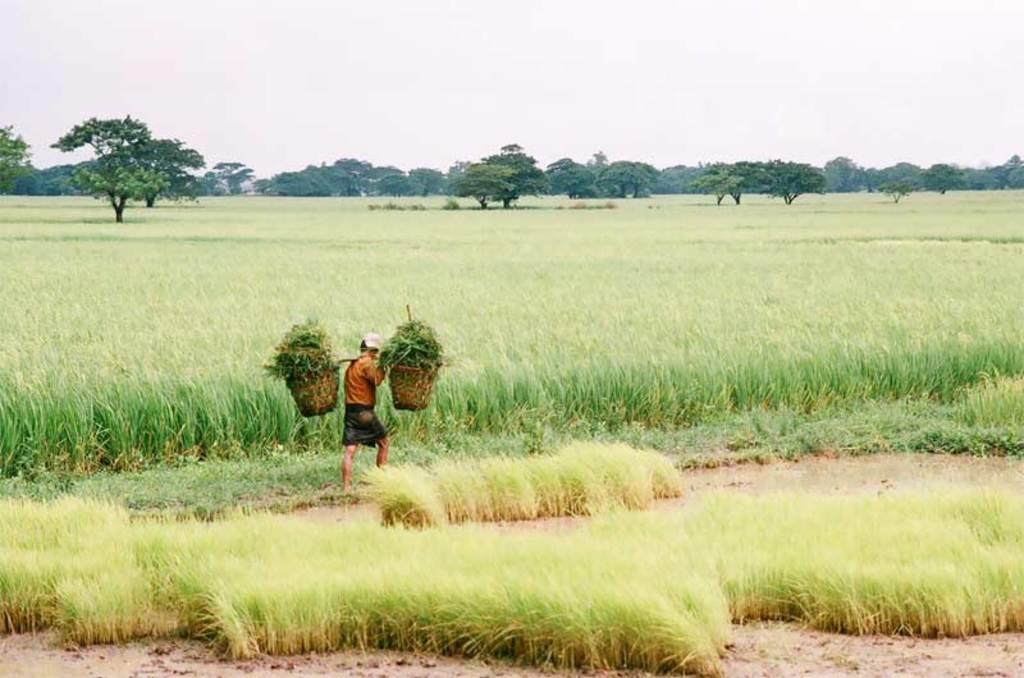What is the main setting of the image? There is a field in the image. What is the person in the image doing? The person is holding baskets with grass. What can be seen in the background of the image? There are trees and the sky visible in the background of the image. How many eyes can be seen on the grass in the image? There are no eyes visible on the grass in the image, as grass does not have eyes. 